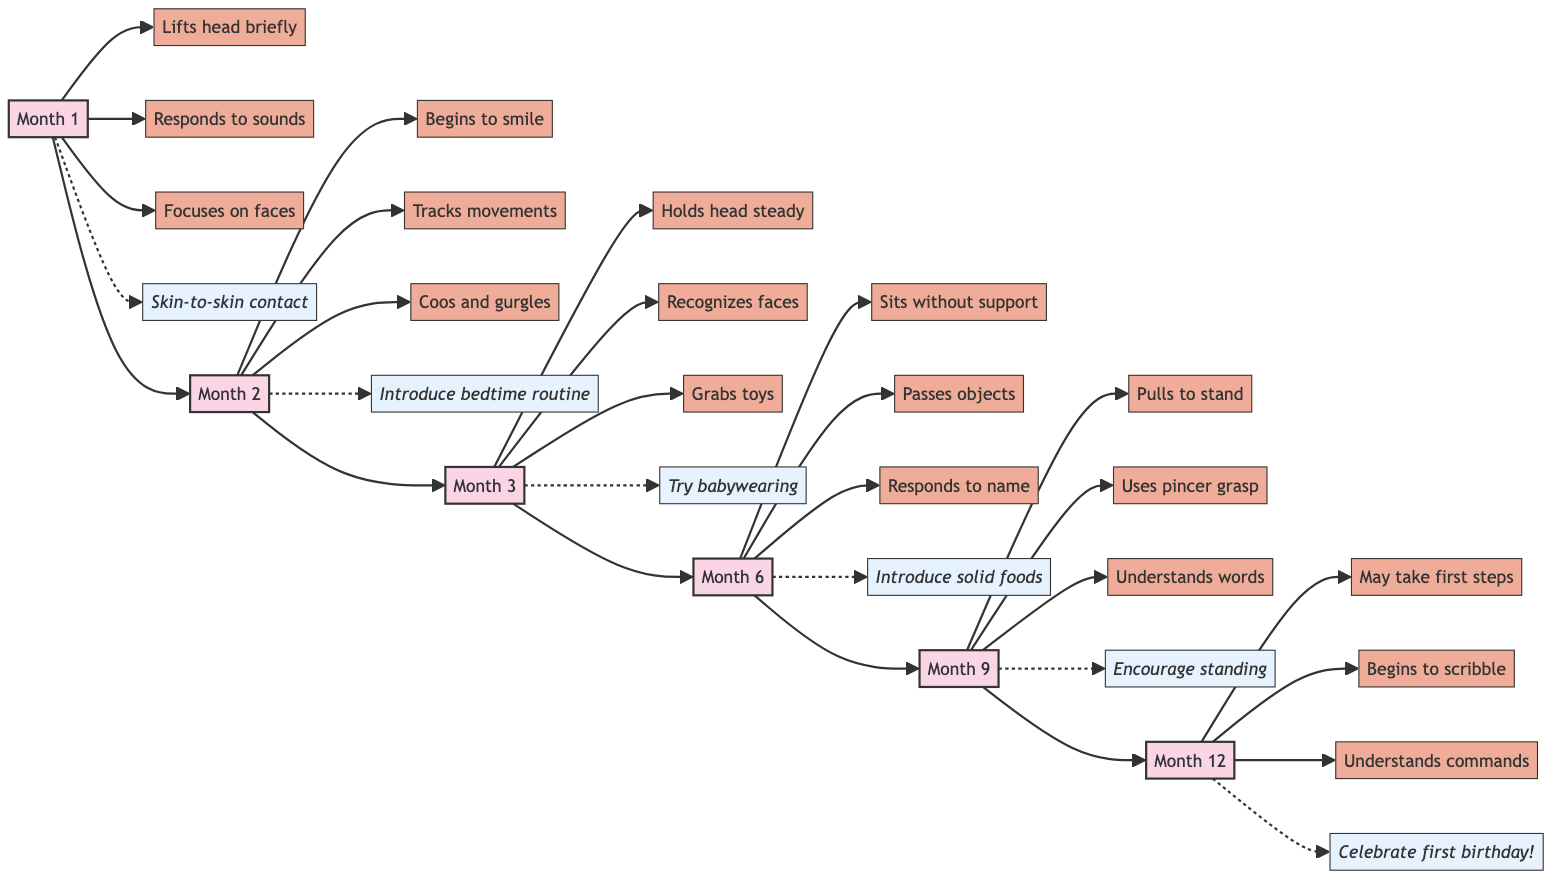What are the key developments for Month 4? From the diagram, Month 4 lists the milestones below the month node: "Pushes down on legs when feet are on a hard surface," "Babbles with expression," and "Brings hands to mouth."
Answer: Pushes down on legs, Babbles with expression, Brings hands to mouth Which month shows key developments for crawling? By looking at the diagram, the milestone "Crawls" is connected to Month 8. This is the only month listed that includes crawling as a key development.
Answer: Month 8 How many total milestones are listed for Month 1? Examining Month 1, we see three key developments: "Lifts head briefly during tummy time," "Responds to loud sounds," and "Focuses on faces." Therefore, there are three milestones for Month 1.
Answer: 3 What personal advice is given for Month 6? Consulting the flowchart, the advice linked to Month 6 is "Introduce more solid foods—experiment with different textures and flavors," and "Be prepared for separation anxiety and stay calm to reassure your baby."
Answer: Introduce more solid foods, Be prepared for separation anxiety In which month does the baby start to say 'mama' and 'dada' with meaning? Month 11 is where the specific milestone "Says 'mama' and 'dada' with meaning" is indicated in the diagram as a key development.
Answer: Month 11 List the months in chronological order that have their milestones connected to personal advice. The diagram flows from Month 1 to Month 12, showing that personal advice is associated with every month listed. The chronological order includes Months 1, 2, 3, 4, 5, 6, 7, 8, 9, 10, 11, and 12.
Answer: 1, 2, 3, 4, 5, 6, 7, 8, 9, 10, 11, 12 What is the final milestone in the chart? Observing Month 12, the last key development stated is "Understands simple commands." Since it is the last month displayed, this is the final milestone in the chart.
Answer: Understands simple commands How does the chart represent the relationship between months and key developments? The modern flowchart design demonstrates this relationship by having each month connected to its respective key developments through directed arrows, indicating progression through the first year.
Answer: Through directed arrows 